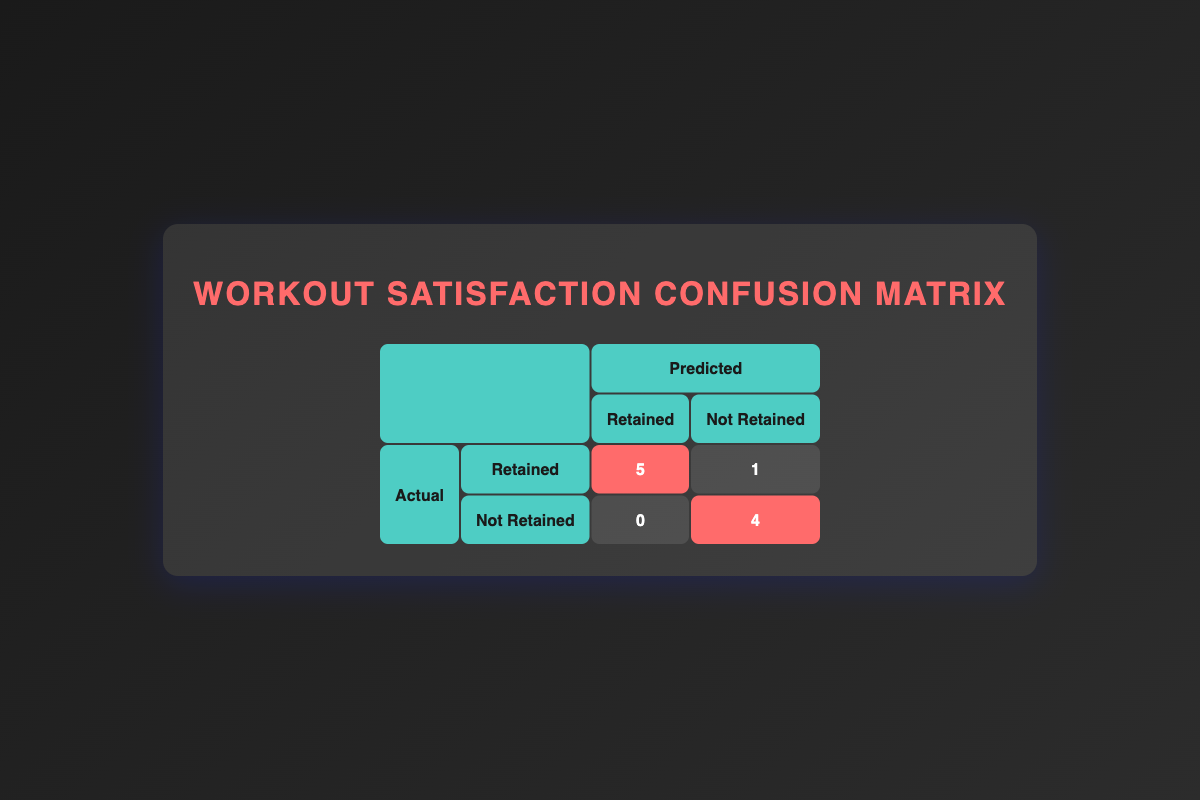What is the total number of members retained? Looking at the confusion matrix, we can see that the predicted 'Retained' and 'Actual Retained' categories are represented by the number 5. So the total number of members retained is simply the value in that cell.
Answer: 5 How many members were not retained? The confusion matrix shows that under 'Actual Not Retained', there are 4 members indicated by the highlighted cell in the 'Not Retained' column. Thus, the total number of members not retained is 4.
Answer: 4 What is the total number of members surveyed? The table consists of the following groups: 'Retained' (members who stayed) with a total of 6 and 'Not Retained' (members who left) with a total of 5, leading to the total as 5 + 4 = 9 members.
Answer: 9 Is it true that all members with a 'High' satisfaction level were retained? To determine this, we can check the predicted retention of members with 'High' satisfaction. There are 5 members under 'High', and all are indicated as retained. Therefore, the statement is true.
Answer: Yes What is the number of members who were predicted to be retained but did not actually retain? The confusion matrix reveals that out of the members predicted to be retained (which is 5), there were 0 that did not actually retain, thus showcasing a perfect prediction for this group.
Answer: 0 Was there any member with a 'Low' satisfaction who was retained? By reviewing the confusion matrix, there are 3 members in the 'Low' satisfaction category under the 'Actual Not Retained' column. Since this cell states there are 0 retained in the low category, the answer must be no.
Answer: No If a member has a 'Medium' satisfaction level, what is the likelihood they were retained? The confusion matrix shows there are 2 members with 'Medium' satisfaction, of which 1 is retained. The chance is 1 out of 2, hence the likelihood is 50%.
Answer: 50% How many more members were retained compared to those not retained? By examining the two categories, we can tally that there are 5 members who were retained and 4 who were not retained, leading to a difference of 5 - 4 = 1 member. Therefore, more members were retained by 1.
Answer: 1 